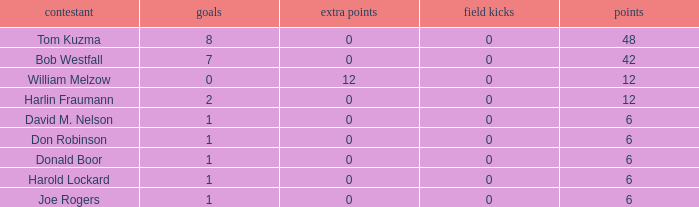Name the least touchdowns for joe rogers 1.0. 